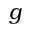<formula> <loc_0><loc_0><loc_500><loc_500>g</formula> 